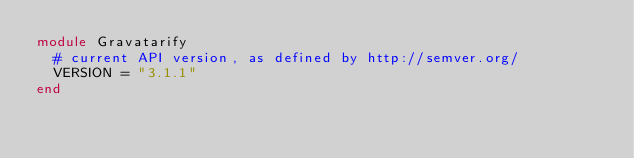<code> <loc_0><loc_0><loc_500><loc_500><_Ruby_>module Gravatarify
  # current API version, as defined by http://semver.org/
  VERSION = "3.1.1"
end
</code> 